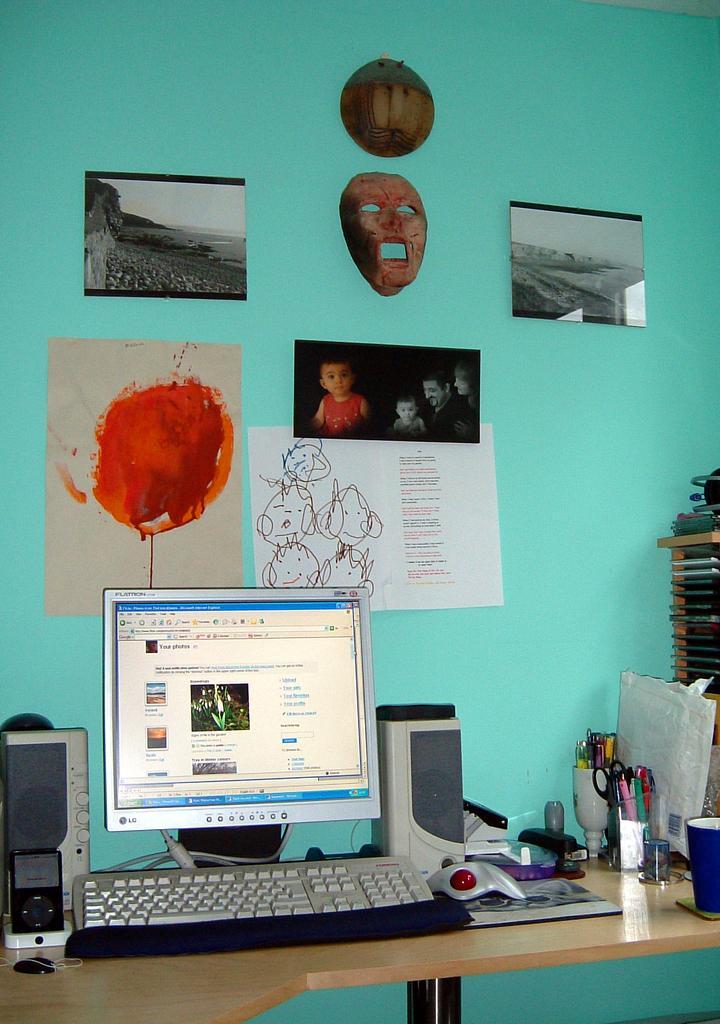How would you summarize this image in a sentence or two? In this picture I can observe a computer placed on the cream color table. On the right side I can observe some accessories. There are some photographs and charts on the wall. The wall is in green color. 